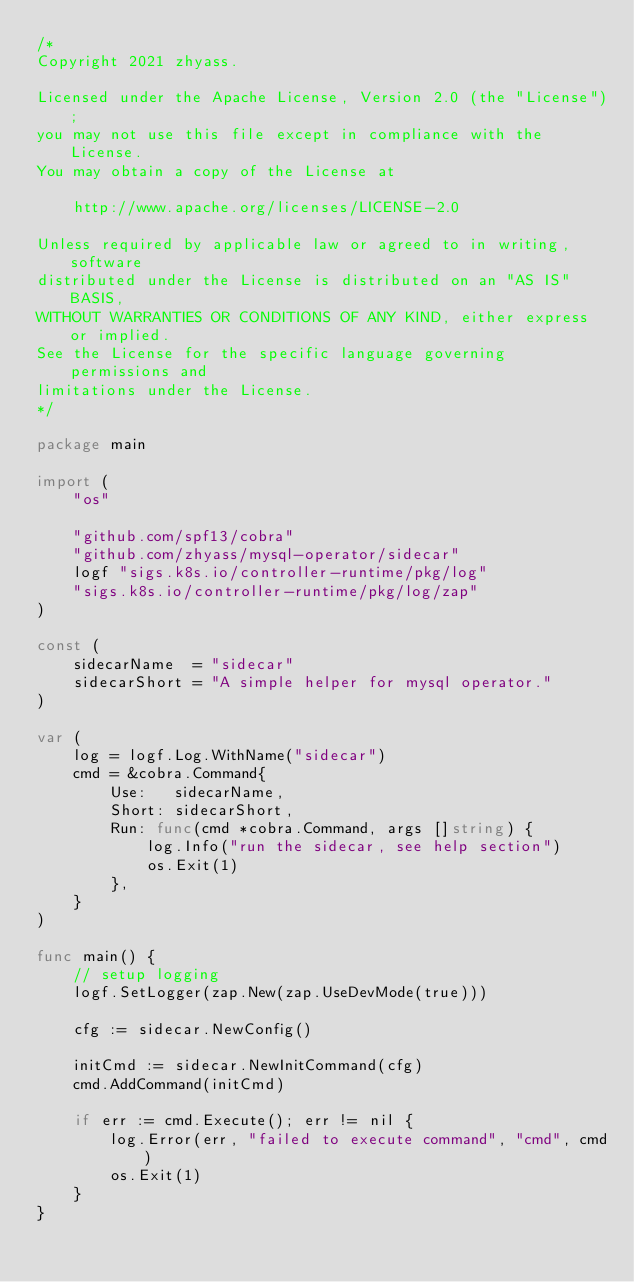<code> <loc_0><loc_0><loc_500><loc_500><_Go_>/*
Copyright 2021 zhyass.

Licensed under the Apache License, Version 2.0 (the "License");
you may not use this file except in compliance with the License.
You may obtain a copy of the License at

    http://www.apache.org/licenses/LICENSE-2.0

Unless required by applicable law or agreed to in writing, software
distributed under the License is distributed on an "AS IS" BASIS,
WITHOUT WARRANTIES OR CONDITIONS OF ANY KIND, either express or implied.
See the License for the specific language governing permissions and
limitations under the License.
*/

package main

import (
	"os"

	"github.com/spf13/cobra"
	"github.com/zhyass/mysql-operator/sidecar"
	logf "sigs.k8s.io/controller-runtime/pkg/log"
	"sigs.k8s.io/controller-runtime/pkg/log/zap"
)

const (
	sidecarName  = "sidecar"
	sidecarShort = "A simple helper for mysql operator."
)

var (
	log = logf.Log.WithName("sidecar")
	cmd = &cobra.Command{
		Use:   sidecarName,
		Short: sidecarShort,
		Run: func(cmd *cobra.Command, args []string) {
			log.Info("run the sidecar, see help section")
			os.Exit(1)
		},
	}
)

func main() {
	// setup logging
	logf.SetLogger(zap.New(zap.UseDevMode(true)))

	cfg := sidecar.NewConfig()

	initCmd := sidecar.NewInitCommand(cfg)
	cmd.AddCommand(initCmd)

	if err := cmd.Execute(); err != nil {
		log.Error(err, "failed to execute command", "cmd", cmd)
		os.Exit(1)
	}
}
</code> 